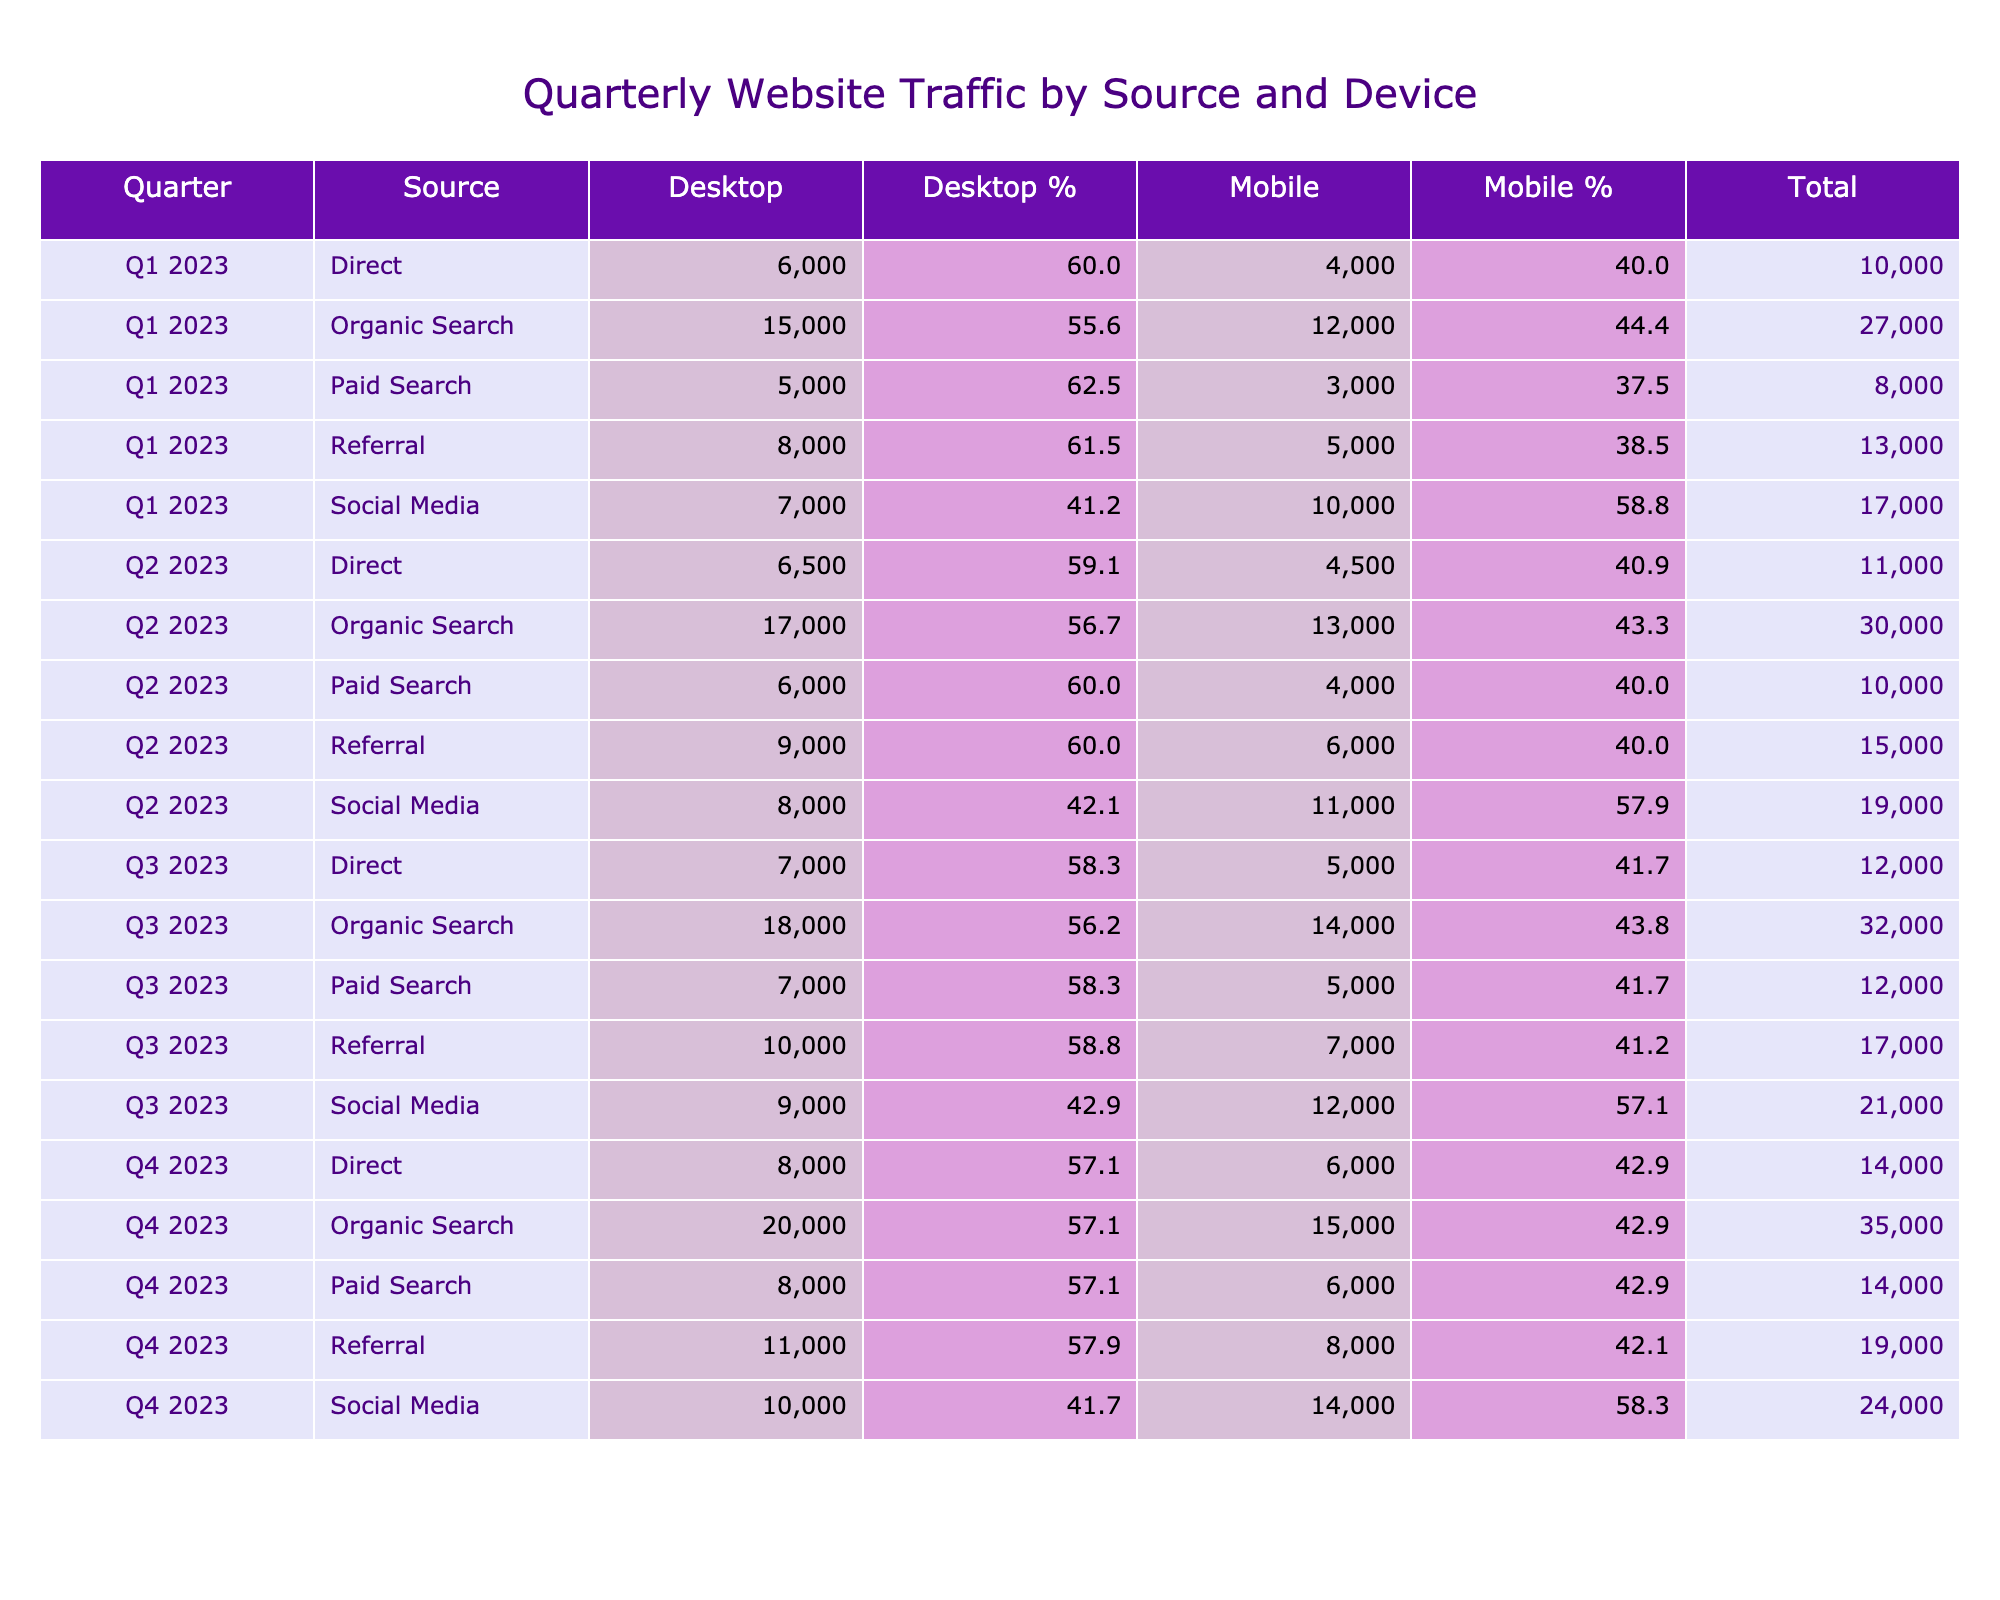What was the total traffic from Organic Search in Q2 2023? For Q2 2023, the traffic from Organic Search on Desktop is 17,000 and on Mobile it is 13,000. Adding these together gives a total of 17,000 + 13,000 = 30,000.
Answer: 30,000 Which source had the highest Mobile traffic in Q3 2023? In Q3 2023, the Mobile traffic values are: Organic Search (14,000), Paid Search (5,000), Social Media (12,000), Referral (7,000), and Direct (5,000). The highest is 14,000 from Organic Search.
Answer: Organic Search Is the total traffic for Direct traffic in Q1 2023 higher than that in Q2 2023? The total traffic for Direct in Q1 2023 is 6,000 (Desktop) + 4,000 (Mobile) = 10,000. In Q2 2023, it is 6,500 (Desktop) + 4,500 (Mobile) = 11,000. Since 10,000 is less than 11,000, the statement is false.
Answer: No What percentage of the total traffic in Q4 2023 came from Mobile? In Q4 2023, the total traffic is 20,000 (Desktop) + 15,000 (Mobile) = 35,000. The Mobile traffic is 15,000, so the percentage is (15,000 / 35,000) * 100 ≈ 42.9%.
Answer: 42.9% Which quarter saw the most overall traffic from Social Media? Summing up traffic from Social Media: Q1 2023 = 7,000 (Desktop) + 10,000 (Mobile) = 17,000, Q2 2023 = 8,000 + 11,000 = 19,000, Q3 2023 = 9,000 + 12,000 = 21,000, and Q4 2023 = 10,000 + 14,000 = 24,000. The highest is 24,000 in Q4 2023.
Answer: Q4 2023 Was the traffic from Paid Search on Desktop higher than the traffic from Referral on Desktop in Q1 2023? For Q1 2023, Paid Search Desktop traffic is 5,000 while Referral Desktop traffic is 8,000. Since 5,000 is less than 8,000, the answer is no.
Answer: No Calculate the average traffic from Organic Search across all four quarters. The Organic Search traffic is: Q1 = 15,000 + 12,000 = 27,000, Q2 = 17,000 + 13,000 = 30,000, Q3 = 18,000 + 14,000 = 32,000, Q4 = 20,000 + 15,000 = 35,000. The total is 27,000 + 30,000 + 32,000 + 35,000 = 124,000. The average is 124,000 / 4 = 31,000.
Answer: 31,000 In which quarter did the Direct traffic see the largest increase from the previous quarter? The Direct traffic for each quarter is: Q1 = 10,000, Q2 = 11,000, Q3 = 12,000, and Q4 = 14,000. The increases are: Q1 to Q2 = 1,000, Q2 to Q3 = 1,000, Q3 to Q4 = 2,000. The largest increase is from Q3 to Q4 with an increase of 2,000.
Answer: Q4 2023 What trend can we observe in the traffic from Organic Search over the four quarters? The traffic from Organic Search is: Q1 = 27,000, Q2 = 30,000, Q3 = 32,000, Q4 = 35,000. Each quarter shows an increase, indicating a consistent upward trend in Organic Search traffic throughout the year.
Answer: Increasing trend 